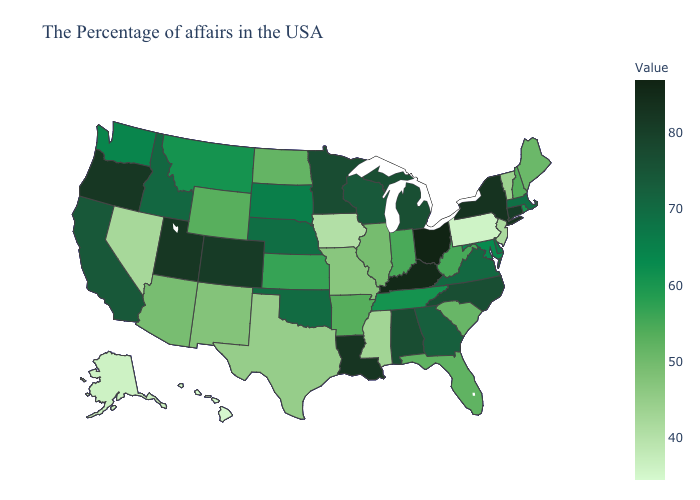Does Connecticut have the highest value in the Northeast?
Concise answer only. No. Does Washington have a higher value than Colorado?
Give a very brief answer. No. Among the states that border North Dakota , does South Dakota have the lowest value?
Answer briefly. No. Which states hav the highest value in the West?
Write a very short answer. Oregon. Does Mississippi have the lowest value in the South?
Be succinct. Yes. Which states have the highest value in the USA?
Answer briefly. Ohio. 